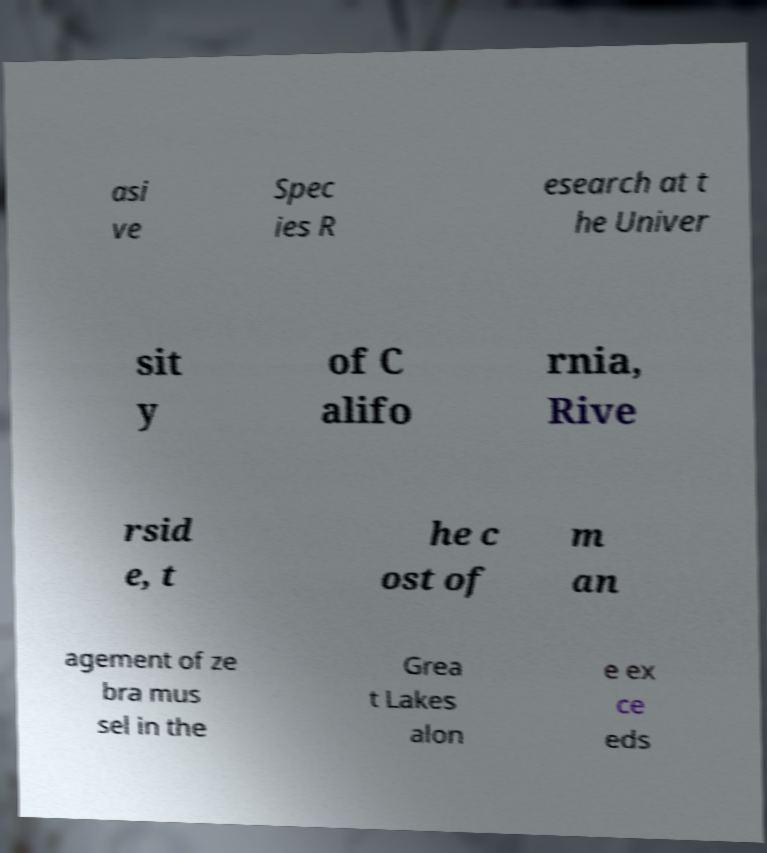Can you accurately transcribe the text from the provided image for me? asi ve Spec ies R esearch at t he Univer sit y of C alifo rnia, Rive rsid e, t he c ost of m an agement of ze bra mus sel in the Grea t Lakes alon e ex ce eds 